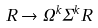<formula> <loc_0><loc_0><loc_500><loc_500>R \rightarrow \Omega ^ { k } \Sigma ^ { k } R</formula> 